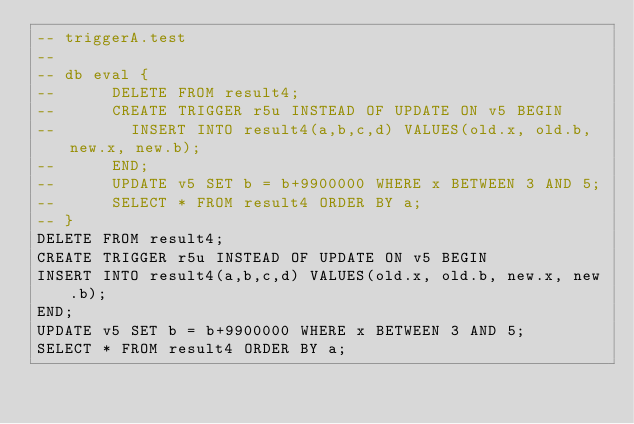<code> <loc_0><loc_0><loc_500><loc_500><_SQL_>-- triggerA.test
-- 
-- db eval {
--      DELETE FROM result4;
--      CREATE TRIGGER r5u INSTEAD OF UPDATE ON v5 BEGIN
--        INSERT INTO result4(a,b,c,d) VALUES(old.x, old.b, new.x, new.b);
--      END;
--      UPDATE v5 SET b = b+9900000 WHERE x BETWEEN 3 AND 5;
--      SELECT * FROM result4 ORDER BY a;
-- }
DELETE FROM result4;
CREATE TRIGGER r5u INSTEAD OF UPDATE ON v5 BEGIN
INSERT INTO result4(a,b,c,d) VALUES(old.x, old.b, new.x, new.b);
END;
UPDATE v5 SET b = b+9900000 WHERE x BETWEEN 3 AND 5;
SELECT * FROM result4 ORDER BY a;</code> 